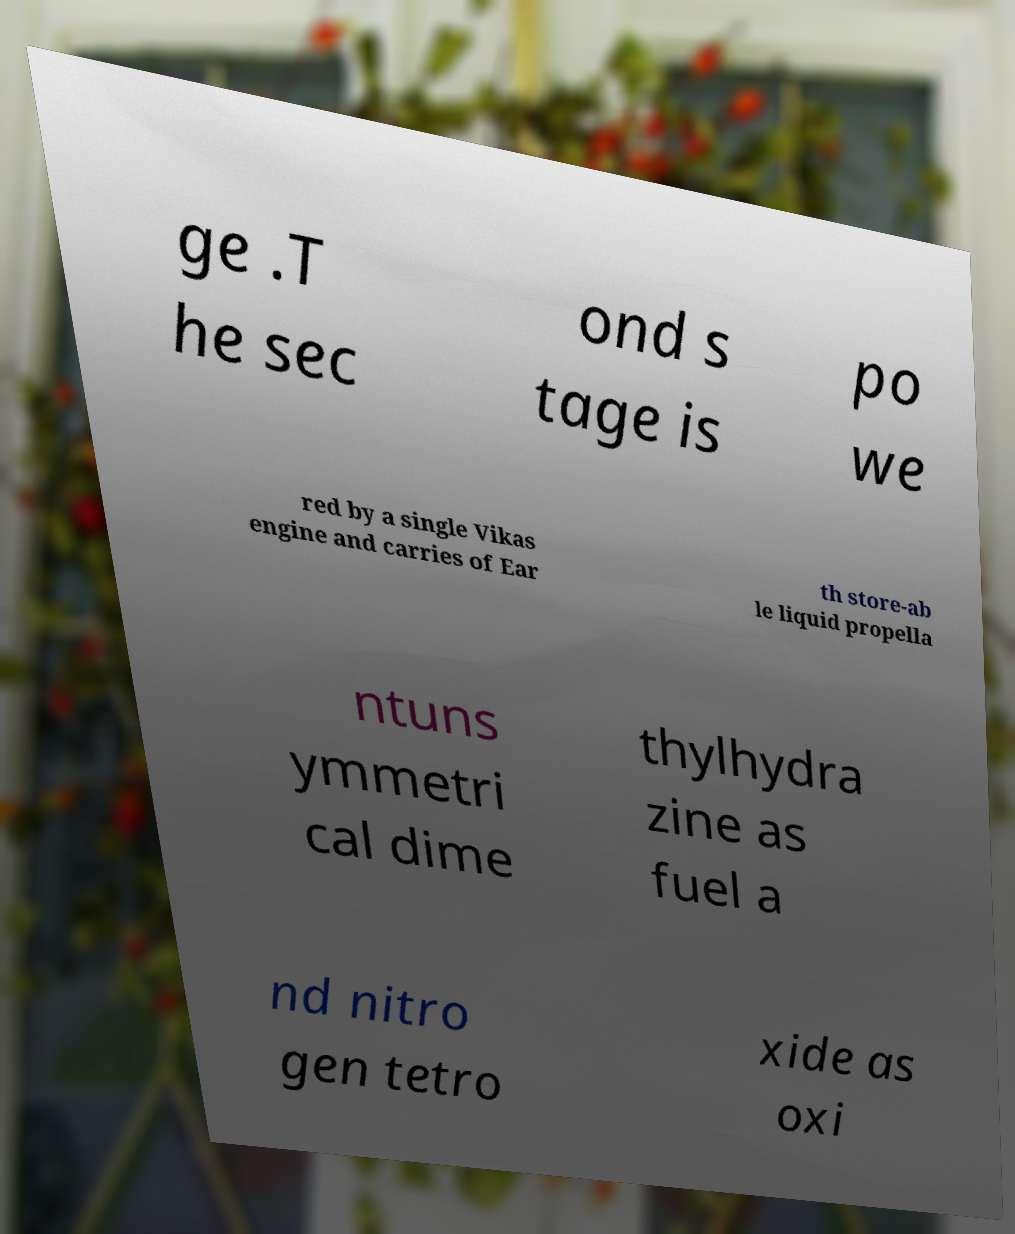Can you read and provide the text displayed in the image?This photo seems to have some interesting text. Can you extract and type it out for me? ge .T he sec ond s tage is po we red by a single Vikas engine and carries of Ear th store-ab le liquid propella ntuns ymmetri cal dime thylhydra zine as fuel a nd nitro gen tetro xide as oxi 